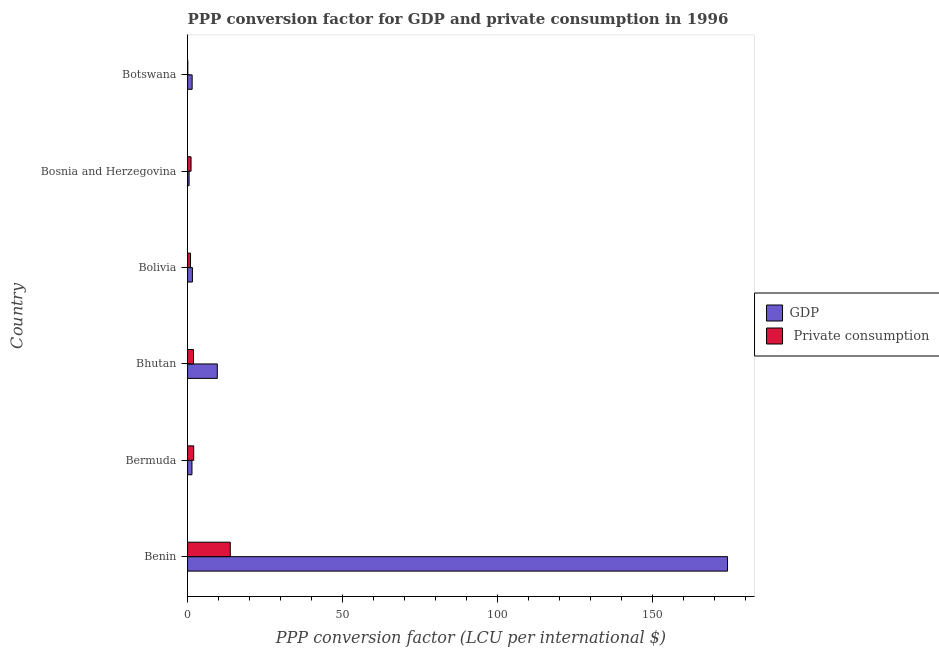How many different coloured bars are there?
Keep it short and to the point. 2. How many groups of bars are there?
Offer a very short reply. 6. Are the number of bars on each tick of the Y-axis equal?
Give a very brief answer. Yes. How many bars are there on the 3rd tick from the bottom?
Provide a short and direct response. 2. What is the label of the 1st group of bars from the top?
Your answer should be very brief. Botswana. In how many cases, is the number of bars for a given country not equal to the number of legend labels?
Your answer should be compact. 0. What is the ppp conversion factor for private consumption in Bolivia?
Your answer should be compact. 0.95. Across all countries, what is the maximum ppp conversion factor for private consumption?
Provide a short and direct response. 13.78. Across all countries, what is the minimum ppp conversion factor for private consumption?
Keep it short and to the point. 0.05. In which country was the ppp conversion factor for gdp maximum?
Keep it short and to the point. Benin. In which country was the ppp conversion factor for private consumption minimum?
Offer a very short reply. Botswana. What is the total ppp conversion factor for gdp in the graph?
Offer a terse response. 188.8. What is the difference between the ppp conversion factor for gdp in Benin and that in Botswana?
Provide a succinct answer. 172.83. What is the difference between the ppp conversion factor for private consumption in Benin and the ppp conversion factor for gdp in Bhutan?
Give a very brief answer. 4.19. What is the average ppp conversion factor for private consumption per country?
Provide a short and direct response. 3.29. What is the difference between the ppp conversion factor for gdp and ppp conversion factor for private consumption in Bolivia?
Make the answer very short. 0.61. In how many countries, is the ppp conversion factor for gdp greater than 20 LCU?
Make the answer very short. 1. What is the ratio of the ppp conversion factor for gdp in Bermuda to that in Bhutan?
Your response must be concise. 0.15. Is the ppp conversion factor for private consumption in Benin less than that in Bolivia?
Provide a short and direct response. No. Is the difference between the ppp conversion factor for gdp in Bhutan and Botswana greater than the difference between the ppp conversion factor for private consumption in Bhutan and Botswana?
Give a very brief answer. Yes. What is the difference between the highest and the second highest ppp conversion factor for gdp?
Your answer should be compact. 164.71. What is the difference between the highest and the lowest ppp conversion factor for gdp?
Provide a succinct answer. 173.81. In how many countries, is the ppp conversion factor for private consumption greater than the average ppp conversion factor for private consumption taken over all countries?
Give a very brief answer. 1. What does the 2nd bar from the top in Bolivia represents?
Your response must be concise. GDP. What does the 1st bar from the bottom in Benin represents?
Your answer should be very brief. GDP. Are all the bars in the graph horizontal?
Give a very brief answer. Yes. What is the difference between two consecutive major ticks on the X-axis?
Offer a very short reply. 50. Are the values on the major ticks of X-axis written in scientific E-notation?
Provide a succinct answer. No. Does the graph contain grids?
Your answer should be very brief. No. Where does the legend appear in the graph?
Give a very brief answer. Center right. How are the legend labels stacked?
Offer a very short reply. Vertical. What is the title of the graph?
Offer a terse response. PPP conversion factor for GDP and private consumption in 1996. What is the label or title of the X-axis?
Your answer should be very brief. PPP conversion factor (LCU per international $). What is the label or title of the Y-axis?
Ensure brevity in your answer.  Country. What is the PPP conversion factor (LCU per international $) of GDP in Benin?
Offer a terse response. 174.29. What is the PPP conversion factor (LCU per international $) of  Private consumption in Benin?
Make the answer very short. 13.78. What is the PPP conversion factor (LCU per international $) of GDP in Bermuda?
Give a very brief answer. 1.41. What is the PPP conversion factor (LCU per international $) in  Private consumption in Bermuda?
Offer a terse response. 1.97. What is the PPP conversion factor (LCU per international $) in GDP in Bhutan?
Give a very brief answer. 9.59. What is the PPP conversion factor (LCU per international $) in  Private consumption in Bhutan?
Make the answer very short. 1.9. What is the PPP conversion factor (LCU per international $) in GDP in Bolivia?
Ensure brevity in your answer.  1.56. What is the PPP conversion factor (LCU per international $) in  Private consumption in Bolivia?
Your answer should be very brief. 0.95. What is the PPP conversion factor (LCU per international $) of GDP in Bosnia and Herzegovina?
Make the answer very short. 0.48. What is the PPP conversion factor (LCU per international $) in  Private consumption in Bosnia and Herzegovina?
Give a very brief answer. 1.11. What is the PPP conversion factor (LCU per international $) in GDP in Botswana?
Offer a very short reply. 1.47. What is the PPP conversion factor (LCU per international $) in  Private consumption in Botswana?
Provide a succinct answer. 0.05. Across all countries, what is the maximum PPP conversion factor (LCU per international $) of GDP?
Your response must be concise. 174.29. Across all countries, what is the maximum PPP conversion factor (LCU per international $) of  Private consumption?
Your answer should be compact. 13.78. Across all countries, what is the minimum PPP conversion factor (LCU per international $) in GDP?
Make the answer very short. 0.48. Across all countries, what is the minimum PPP conversion factor (LCU per international $) of  Private consumption?
Give a very brief answer. 0.05. What is the total PPP conversion factor (LCU per international $) in GDP in the graph?
Provide a short and direct response. 188.8. What is the total PPP conversion factor (LCU per international $) in  Private consumption in the graph?
Offer a terse response. 19.76. What is the difference between the PPP conversion factor (LCU per international $) in GDP in Benin and that in Bermuda?
Make the answer very short. 172.88. What is the difference between the PPP conversion factor (LCU per international $) of  Private consumption in Benin and that in Bermuda?
Your response must be concise. 11.8. What is the difference between the PPP conversion factor (LCU per international $) of GDP in Benin and that in Bhutan?
Ensure brevity in your answer.  164.7. What is the difference between the PPP conversion factor (LCU per international $) in  Private consumption in Benin and that in Bhutan?
Your answer should be compact. 11.87. What is the difference between the PPP conversion factor (LCU per international $) in GDP in Benin and that in Bolivia?
Make the answer very short. 172.74. What is the difference between the PPP conversion factor (LCU per international $) of  Private consumption in Benin and that in Bolivia?
Offer a terse response. 12.83. What is the difference between the PPP conversion factor (LCU per international $) in GDP in Benin and that in Bosnia and Herzegovina?
Give a very brief answer. 173.81. What is the difference between the PPP conversion factor (LCU per international $) of  Private consumption in Benin and that in Bosnia and Herzegovina?
Your answer should be very brief. 12.66. What is the difference between the PPP conversion factor (LCU per international $) of GDP in Benin and that in Botswana?
Offer a very short reply. 172.83. What is the difference between the PPP conversion factor (LCU per international $) in  Private consumption in Benin and that in Botswana?
Keep it short and to the point. 13.72. What is the difference between the PPP conversion factor (LCU per international $) of GDP in Bermuda and that in Bhutan?
Give a very brief answer. -8.18. What is the difference between the PPP conversion factor (LCU per international $) in  Private consumption in Bermuda and that in Bhutan?
Your response must be concise. 0.07. What is the difference between the PPP conversion factor (LCU per international $) of GDP in Bermuda and that in Bolivia?
Your answer should be very brief. -0.15. What is the difference between the PPP conversion factor (LCU per international $) in  Private consumption in Bermuda and that in Bolivia?
Make the answer very short. 1.03. What is the difference between the PPP conversion factor (LCU per international $) in GDP in Bermuda and that in Bosnia and Herzegovina?
Make the answer very short. 0.93. What is the difference between the PPP conversion factor (LCU per international $) of  Private consumption in Bermuda and that in Bosnia and Herzegovina?
Provide a short and direct response. 0.86. What is the difference between the PPP conversion factor (LCU per international $) of GDP in Bermuda and that in Botswana?
Your answer should be very brief. -0.06. What is the difference between the PPP conversion factor (LCU per international $) in  Private consumption in Bermuda and that in Botswana?
Your response must be concise. 1.92. What is the difference between the PPP conversion factor (LCU per international $) in GDP in Bhutan and that in Bolivia?
Your response must be concise. 8.03. What is the difference between the PPP conversion factor (LCU per international $) in  Private consumption in Bhutan and that in Bolivia?
Ensure brevity in your answer.  0.96. What is the difference between the PPP conversion factor (LCU per international $) of GDP in Bhutan and that in Bosnia and Herzegovina?
Your response must be concise. 9.11. What is the difference between the PPP conversion factor (LCU per international $) of  Private consumption in Bhutan and that in Bosnia and Herzegovina?
Ensure brevity in your answer.  0.79. What is the difference between the PPP conversion factor (LCU per international $) of GDP in Bhutan and that in Botswana?
Make the answer very short. 8.12. What is the difference between the PPP conversion factor (LCU per international $) of  Private consumption in Bhutan and that in Botswana?
Provide a succinct answer. 1.85. What is the difference between the PPP conversion factor (LCU per international $) of GDP in Bolivia and that in Bosnia and Herzegovina?
Ensure brevity in your answer.  1.08. What is the difference between the PPP conversion factor (LCU per international $) of  Private consumption in Bolivia and that in Bosnia and Herzegovina?
Ensure brevity in your answer.  -0.17. What is the difference between the PPP conversion factor (LCU per international $) in GDP in Bolivia and that in Botswana?
Make the answer very short. 0.09. What is the difference between the PPP conversion factor (LCU per international $) of  Private consumption in Bolivia and that in Botswana?
Your response must be concise. 0.89. What is the difference between the PPP conversion factor (LCU per international $) in GDP in Bosnia and Herzegovina and that in Botswana?
Keep it short and to the point. -0.99. What is the difference between the PPP conversion factor (LCU per international $) of  Private consumption in Bosnia and Herzegovina and that in Botswana?
Your response must be concise. 1.06. What is the difference between the PPP conversion factor (LCU per international $) of GDP in Benin and the PPP conversion factor (LCU per international $) of  Private consumption in Bermuda?
Make the answer very short. 172.32. What is the difference between the PPP conversion factor (LCU per international $) of GDP in Benin and the PPP conversion factor (LCU per international $) of  Private consumption in Bhutan?
Your answer should be very brief. 172.39. What is the difference between the PPP conversion factor (LCU per international $) in GDP in Benin and the PPP conversion factor (LCU per international $) in  Private consumption in Bolivia?
Offer a terse response. 173.35. What is the difference between the PPP conversion factor (LCU per international $) in GDP in Benin and the PPP conversion factor (LCU per international $) in  Private consumption in Bosnia and Herzegovina?
Provide a succinct answer. 173.18. What is the difference between the PPP conversion factor (LCU per international $) in GDP in Benin and the PPP conversion factor (LCU per international $) in  Private consumption in Botswana?
Provide a short and direct response. 174.24. What is the difference between the PPP conversion factor (LCU per international $) of GDP in Bermuda and the PPP conversion factor (LCU per international $) of  Private consumption in Bhutan?
Offer a very short reply. -0.49. What is the difference between the PPP conversion factor (LCU per international $) of GDP in Bermuda and the PPP conversion factor (LCU per international $) of  Private consumption in Bolivia?
Provide a succinct answer. 0.46. What is the difference between the PPP conversion factor (LCU per international $) of GDP in Bermuda and the PPP conversion factor (LCU per international $) of  Private consumption in Bosnia and Herzegovina?
Ensure brevity in your answer.  0.3. What is the difference between the PPP conversion factor (LCU per international $) in GDP in Bermuda and the PPP conversion factor (LCU per international $) in  Private consumption in Botswana?
Give a very brief answer. 1.36. What is the difference between the PPP conversion factor (LCU per international $) in GDP in Bhutan and the PPP conversion factor (LCU per international $) in  Private consumption in Bolivia?
Keep it short and to the point. 8.64. What is the difference between the PPP conversion factor (LCU per international $) of GDP in Bhutan and the PPP conversion factor (LCU per international $) of  Private consumption in Bosnia and Herzegovina?
Your answer should be very brief. 8.48. What is the difference between the PPP conversion factor (LCU per international $) of GDP in Bhutan and the PPP conversion factor (LCU per international $) of  Private consumption in Botswana?
Keep it short and to the point. 9.54. What is the difference between the PPP conversion factor (LCU per international $) in GDP in Bolivia and the PPP conversion factor (LCU per international $) in  Private consumption in Bosnia and Herzegovina?
Keep it short and to the point. 0.45. What is the difference between the PPP conversion factor (LCU per international $) of GDP in Bolivia and the PPP conversion factor (LCU per international $) of  Private consumption in Botswana?
Offer a very short reply. 1.51. What is the difference between the PPP conversion factor (LCU per international $) of GDP in Bosnia and Herzegovina and the PPP conversion factor (LCU per international $) of  Private consumption in Botswana?
Offer a very short reply. 0.43. What is the average PPP conversion factor (LCU per international $) of GDP per country?
Ensure brevity in your answer.  31.47. What is the average PPP conversion factor (LCU per international $) in  Private consumption per country?
Offer a terse response. 3.29. What is the difference between the PPP conversion factor (LCU per international $) of GDP and PPP conversion factor (LCU per international $) of  Private consumption in Benin?
Your answer should be very brief. 160.52. What is the difference between the PPP conversion factor (LCU per international $) of GDP and PPP conversion factor (LCU per international $) of  Private consumption in Bermuda?
Provide a succinct answer. -0.56. What is the difference between the PPP conversion factor (LCU per international $) in GDP and PPP conversion factor (LCU per international $) in  Private consumption in Bhutan?
Ensure brevity in your answer.  7.69. What is the difference between the PPP conversion factor (LCU per international $) in GDP and PPP conversion factor (LCU per international $) in  Private consumption in Bolivia?
Offer a terse response. 0.61. What is the difference between the PPP conversion factor (LCU per international $) in GDP and PPP conversion factor (LCU per international $) in  Private consumption in Bosnia and Herzegovina?
Keep it short and to the point. -0.63. What is the difference between the PPP conversion factor (LCU per international $) of GDP and PPP conversion factor (LCU per international $) of  Private consumption in Botswana?
Your answer should be very brief. 1.41. What is the ratio of the PPP conversion factor (LCU per international $) of GDP in Benin to that in Bermuda?
Your response must be concise. 123.6. What is the ratio of the PPP conversion factor (LCU per international $) of  Private consumption in Benin to that in Bermuda?
Give a very brief answer. 6.98. What is the ratio of the PPP conversion factor (LCU per international $) of GDP in Benin to that in Bhutan?
Give a very brief answer. 18.17. What is the ratio of the PPP conversion factor (LCU per international $) of  Private consumption in Benin to that in Bhutan?
Your answer should be compact. 7.23. What is the ratio of the PPP conversion factor (LCU per international $) in GDP in Benin to that in Bolivia?
Your response must be concise. 111.78. What is the ratio of the PPP conversion factor (LCU per international $) in  Private consumption in Benin to that in Bolivia?
Ensure brevity in your answer.  14.56. What is the ratio of the PPP conversion factor (LCU per international $) of GDP in Benin to that in Bosnia and Herzegovina?
Your answer should be compact. 361.77. What is the ratio of the PPP conversion factor (LCU per international $) in  Private consumption in Benin to that in Bosnia and Herzegovina?
Make the answer very short. 12.39. What is the ratio of the PPP conversion factor (LCU per international $) in GDP in Benin to that in Botswana?
Keep it short and to the point. 118.72. What is the ratio of the PPP conversion factor (LCU per international $) in  Private consumption in Benin to that in Botswana?
Your response must be concise. 256.75. What is the ratio of the PPP conversion factor (LCU per international $) of GDP in Bermuda to that in Bhutan?
Make the answer very short. 0.15. What is the ratio of the PPP conversion factor (LCU per international $) of  Private consumption in Bermuda to that in Bhutan?
Provide a short and direct response. 1.04. What is the ratio of the PPP conversion factor (LCU per international $) of GDP in Bermuda to that in Bolivia?
Offer a very short reply. 0.9. What is the ratio of the PPP conversion factor (LCU per international $) in  Private consumption in Bermuda to that in Bolivia?
Provide a succinct answer. 2.08. What is the ratio of the PPP conversion factor (LCU per international $) in GDP in Bermuda to that in Bosnia and Herzegovina?
Offer a very short reply. 2.93. What is the ratio of the PPP conversion factor (LCU per international $) in  Private consumption in Bermuda to that in Bosnia and Herzegovina?
Your answer should be compact. 1.77. What is the ratio of the PPP conversion factor (LCU per international $) of GDP in Bermuda to that in Botswana?
Your answer should be very brief. 0.96. What is the ratio of the PPP conversion factor (LCU per international $) of  Private consumption in Bermuda to that in Botswana?
Offer a very short reply. 36.77. What is the ratio of the PPP conversion factor (LCU per international $) in GDP in Bhutan to that in Bolivia?
Offer a very short reply. 6.15. What is the ratio of the PPP conversion factor (LCU per international $) in  Private consumption in Bhutan to that in Bolivia?
Your answer should be compact. 2.01. What is the ratio of the PPP conversion factor (LCU per international $) in GDP in Bhutan to that in Bosnia and Herzegovina?
Give a very brief answer. 19.91. What is the ratio of the PPP conversion factor (LCU per international $) in  Private consumption in Bhutan to that in Bosnia and Herzegovina?
Offer a very short reply. 1.71. What is the ratio of the PPP conversion factor (LCU per international $) in GDP in Bhutan to that in Botswana?
Your response must be concise. 6.53. What is the ratio of the PPP conversion factor (LCU per international $) of  Private consumption in Bhutan to that in Botswana?
Your answer should be very brief. 35.49. What is the ratio of the PPP conversion factor (LCU per international $) of GDP in Bolivia to that in Bosnia and Herzegovina?
Give a very brief answer. 3.24. What is the ratio of the PPP conversion factor (LCU per international $) of  Private consumption in Bolivia to that in Bosnia and Herzegovina?
Your answer should be compact. 0.85. What is the ratio of the PPP conversion factor (LCU per international $) in GDP in Bolivia to that in Botswana?
Offer a terse response. 1.06. What is the ratio of the PPP conversion factor (LCU per international $) of  Private consumption in Bolivia to that in Botswana?
Offer a terse response. 17.64. What is the ratio of the PPP conversion factor (LCU per international $) in GDP in Bosnia and Herzegovina to that in Botswana?
Keep it short and to the point. 0.33. What is the ratio of the PPP conversion factor (LCU per international $) in  Private consumption in Bosnia and Herzegovina to that in Botswana?
Keep it short and to the point. 20.72. What is the difference between the highest and the second highest PPP conversion factor (LCU per international $) in GDP?
Ensure brevity in your answer.  164.7. What is the difference between the highest and the second highest PPP conversion factor (LCU per international $) of  Private consumption?
Your response must be concise. 11.8. What is the difference between the highest and the lowest PPP conversion factor (LCU per international $) in GDP?
Your response must be concise. 173.81. What is the difference between the highest and the lowest PPP conversion factor (LCU per international $) in  Private consumption?
Your answer should be compact. 13.72. 